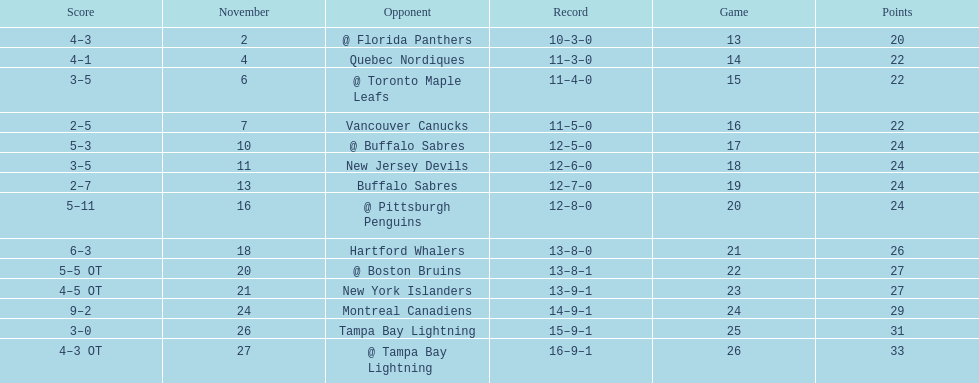Which was the only team in the atlantic division in the 1993-1994 season to acquire less points than the philadelphia flyers? Tampa Bay Lightning. 